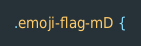<code> <loc_0><loc_0><loc_500><loc_500><_CSS_>.emoji-flag-mD {</code> 